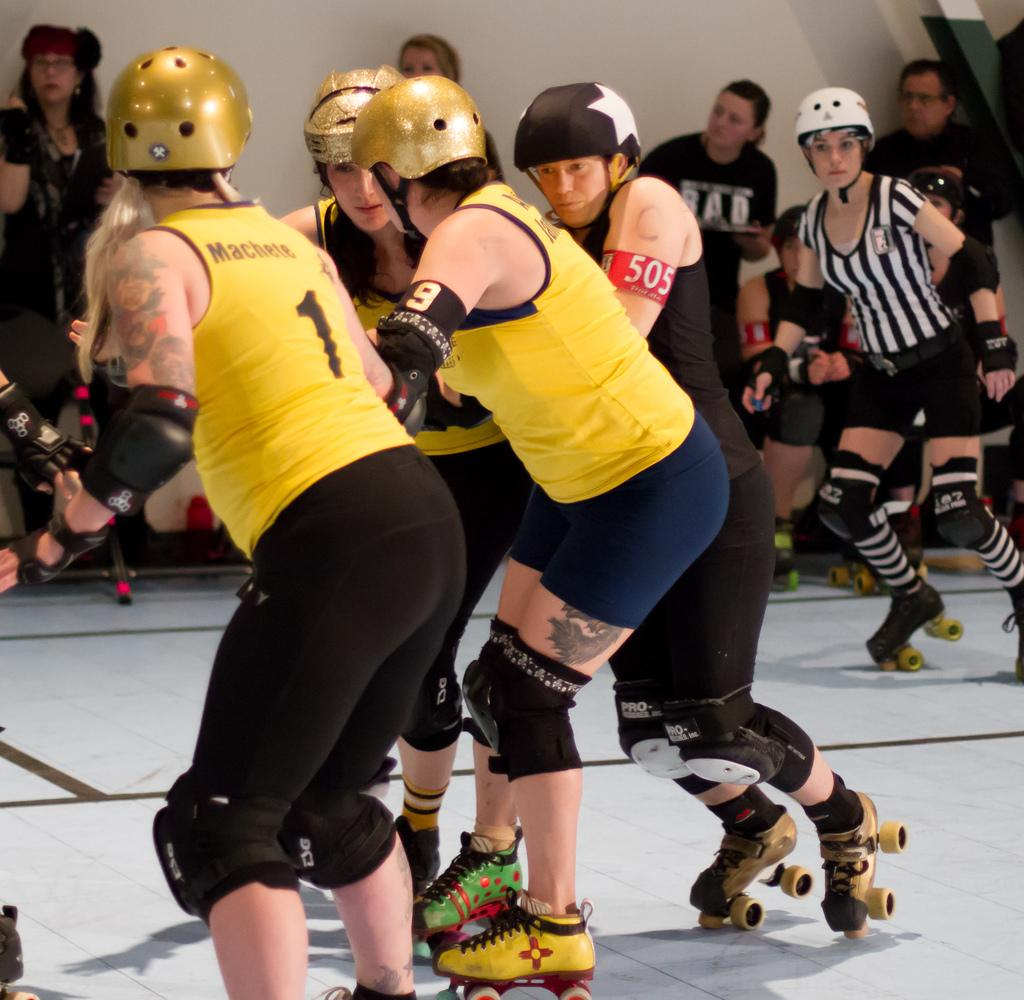Who is present in the image? There are people in the image. What are the people wearing on their heads? The people are wearing helmets. What activity are the people engaged in? The people are skating on the ground. What can be seen in the background of the image? There is a wall in the background of the image, and there are other people visible as well. What type of poison is being used by the people in the image? There is no poison present in the image; the people are skating and wearing helmets. How many minutes does it take for the skaters to complete a lap in the image? The image does not provide information about the duration of the skaters' activity, so it is impossible to determine the number of minutes it takes for them to complete a lap. 